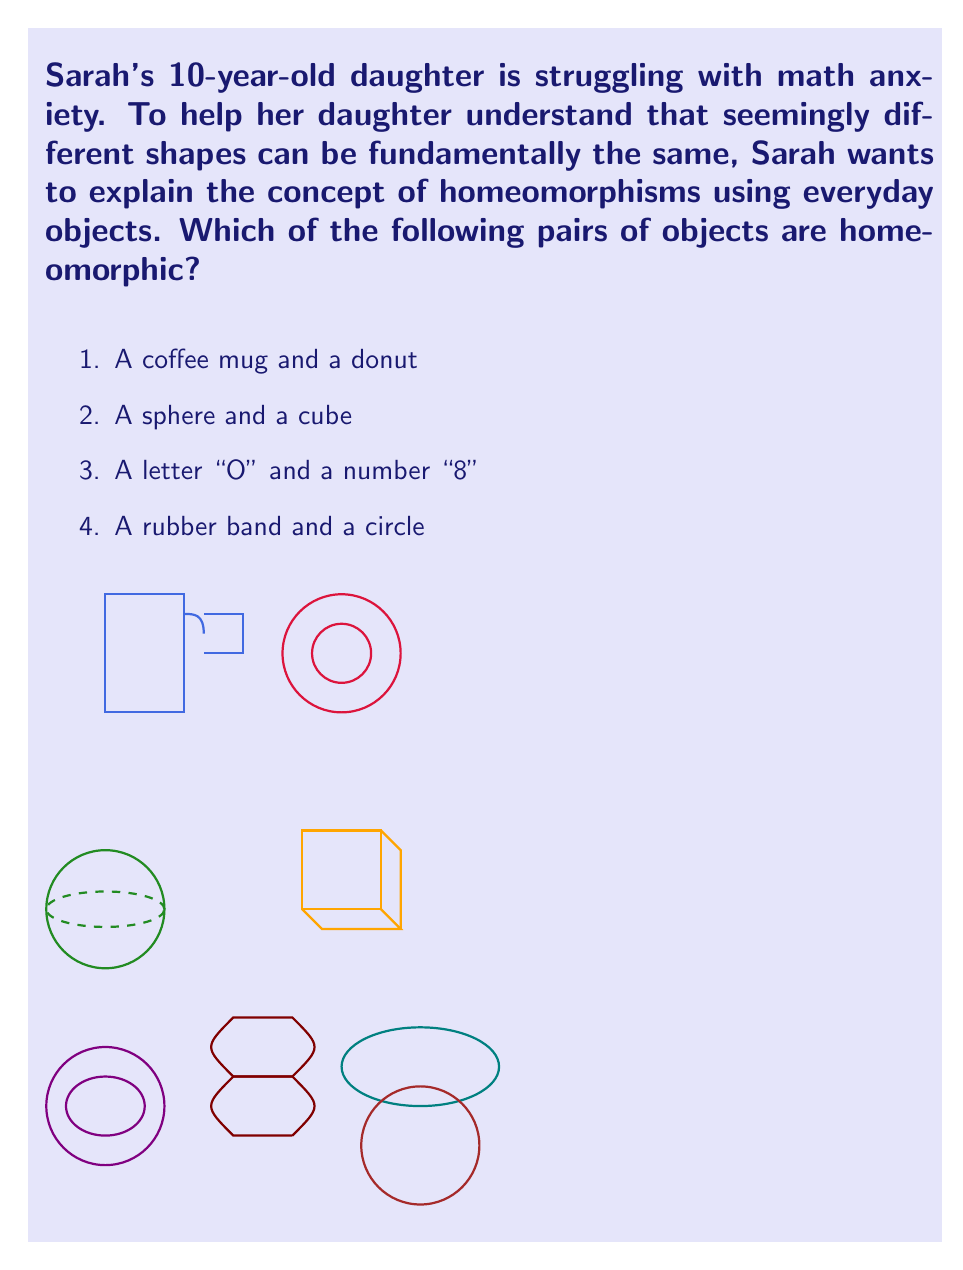Could you help me with this problem? Let's explain the concept of homeomorphisms step-by-step:

1. A homeomorphism is a continuous function between topological spaces that has a continuous inverse function. Intuitively, it allows one to deform one shape into another without cutting, tearing, or gluing.

2. Coffee mug and donut: These are homeomorphic. The handle of the mug can be continuously deformed to form the hole of the donut, and vice versa. This is a classic example in topology.

3. Sphere and cube: These are not homeomorphic. A sphere has no edges or vertices, while a cube has 12 edges and 8 vertices. No continuous deformation can create or remove these features.

4. Letter "O" and number "8": These are not homeomorphic. The letter "O" has one hole, while the number "8" has two holes. The number of holes (technically called the genus) is a topological invariant and cannot be changed by continuous deformation.

5. Rubber band and circle: These are homeomorphic. A rubber band can be stretched into a perfect circle, and a circle can be deformed into the shape of a rubber band, all without cutting or gluing.

To help Sarah's daughter understand, she can use playdough to demonstrate these concepts. She can show how a playdough donut can be reshaped into a coffee mug, or how a circular rubber band can be stretched and deformed while maintaining its fundamental "circle-ness".
Answer: 1 and 4 